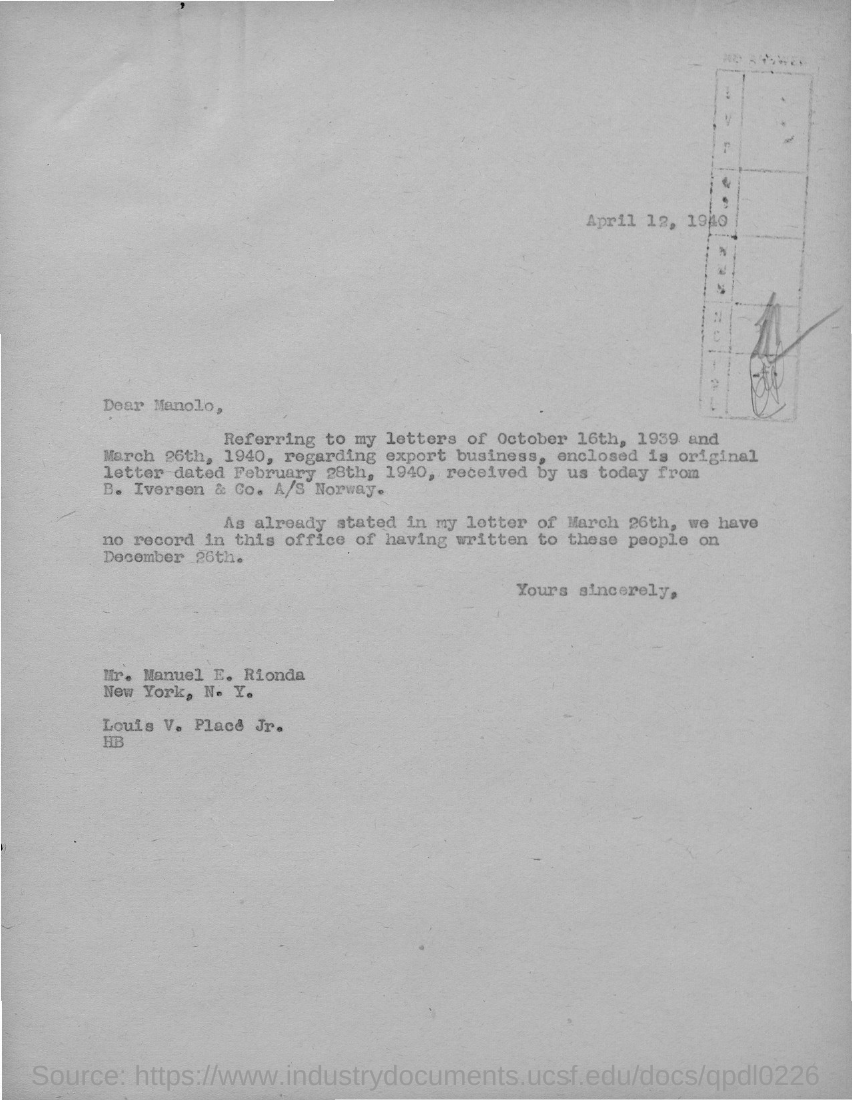Outline some significant characteristics in this image. The letter was sent to Mr. Manuel E. Rionda. The date mentioned on the given page is April 12, 1940. 